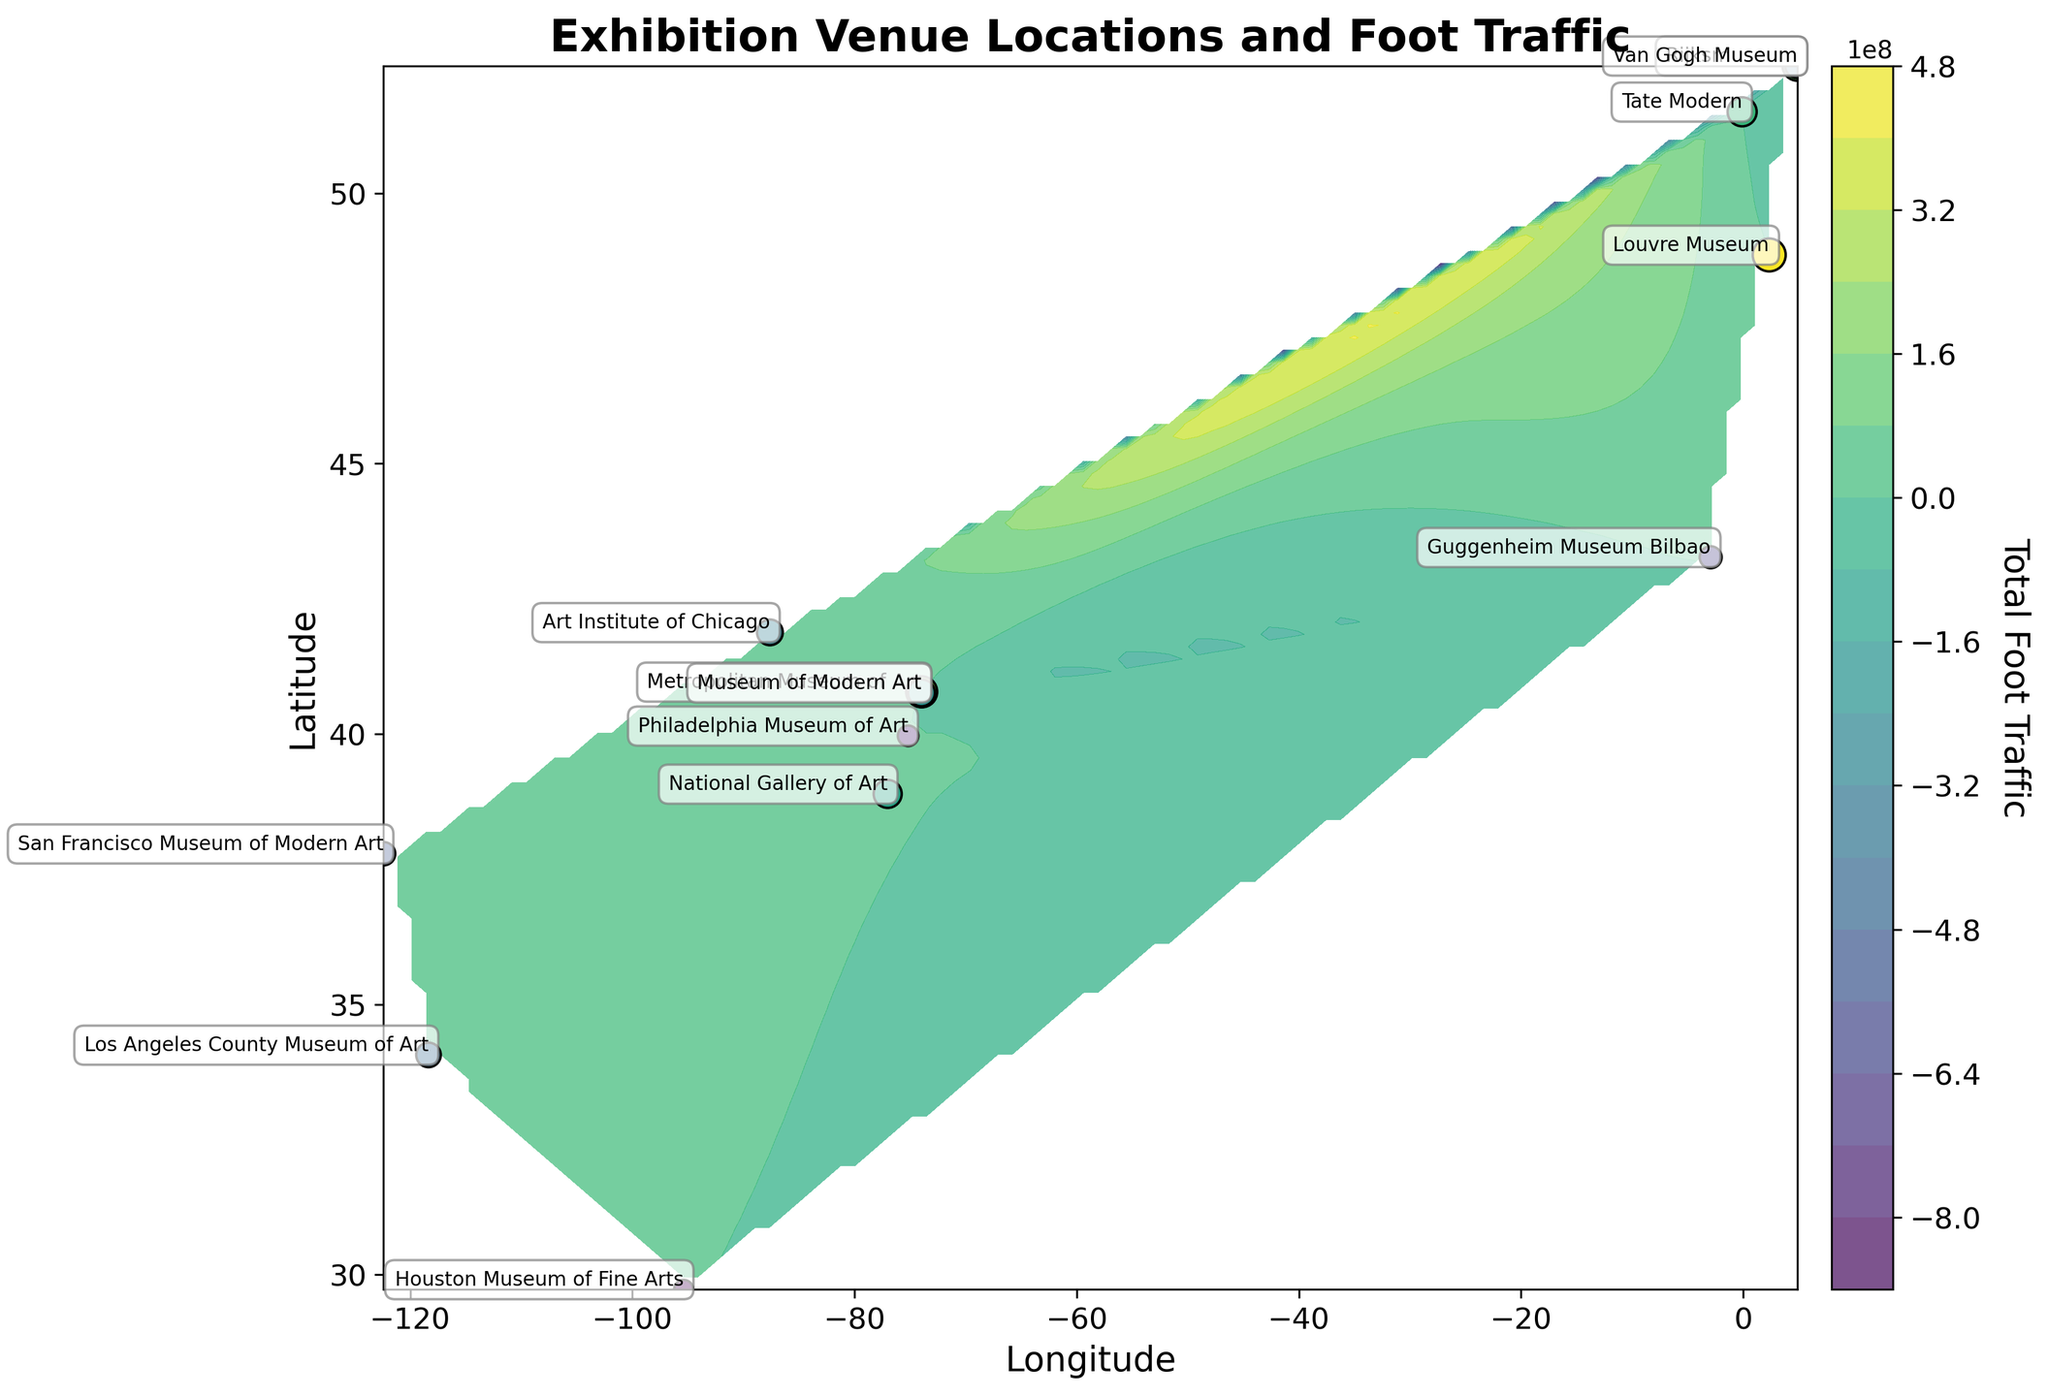1. What is the title of the plot? The title of the plot is located at the top of the figure and describes the content of the plot.
Answer: Exhibition Venue Locations and Foot Traffic 2. How many exhibition venues are displayed as points on the plot? Count the number of labeled scatter points on the plot showing exhibition venues.
Answer: 13 3. What is indicated by the colorbar on the right side of the plot? The colorbar on the right represents the different levels of total foot traffic, with specific colors corresponding to different traffic values.
Answer: Total Foot Traffic 4. What is the range of the latitude axis? The range of the latitude axis can be observed from the y-axis labels.
Answer: Approximately 29 to 52 5. What does each scatter point's size indicate? The size of each scatter point is proportional to the total foot traffic at that exhibition venue, with larger points indicating higher traffic.
Answer: Total Foot Traffic 6. What is the average total foot traffic of the exhibition venues located between latitude 40 and 45? Identify the venues within the given latitude range, then sum their total foot traffic and divide by the number of those venues. The relevant venues are Metropolitan Museum of Art, Museum of Modern Art, and Art Institute of Chicago with traffic values 800,000, 600,000, and 550,000 respectively. The average is (800,000 + 600,000 + 550,000) / 3 = 650,000.
Answer: 650,000 7. Which exhibition venue has the highest total foot traffic? Compare the color and size of scatter points, supplemented by annotations, to identify the venue with the maximum traffic. The Louvre Museum has the largest point and the darkest color.
Answer: Louvre Museum 8. Which exhibition venue has the closest latitude to the Tate Modern's latitude? Identify the latitude of Tate Modern and then compare it with the latitudes of other venues to find the closest one. Tate Modern is at about 51.507642, and Rijksmuseum is close with a latitude of 52.359997.
Answer: Rijksmuseum 9. In which geographical area indicated by the contour plot do we see the highest concentration of high foot traffic exhibition venues? Observe the darkest regions in the contour plot to identify where most high-foot-traffic venues are located. The highest concentration appears to be around Europe (including Louvre Museum and Rijksmuseum).
Answer: Europe 